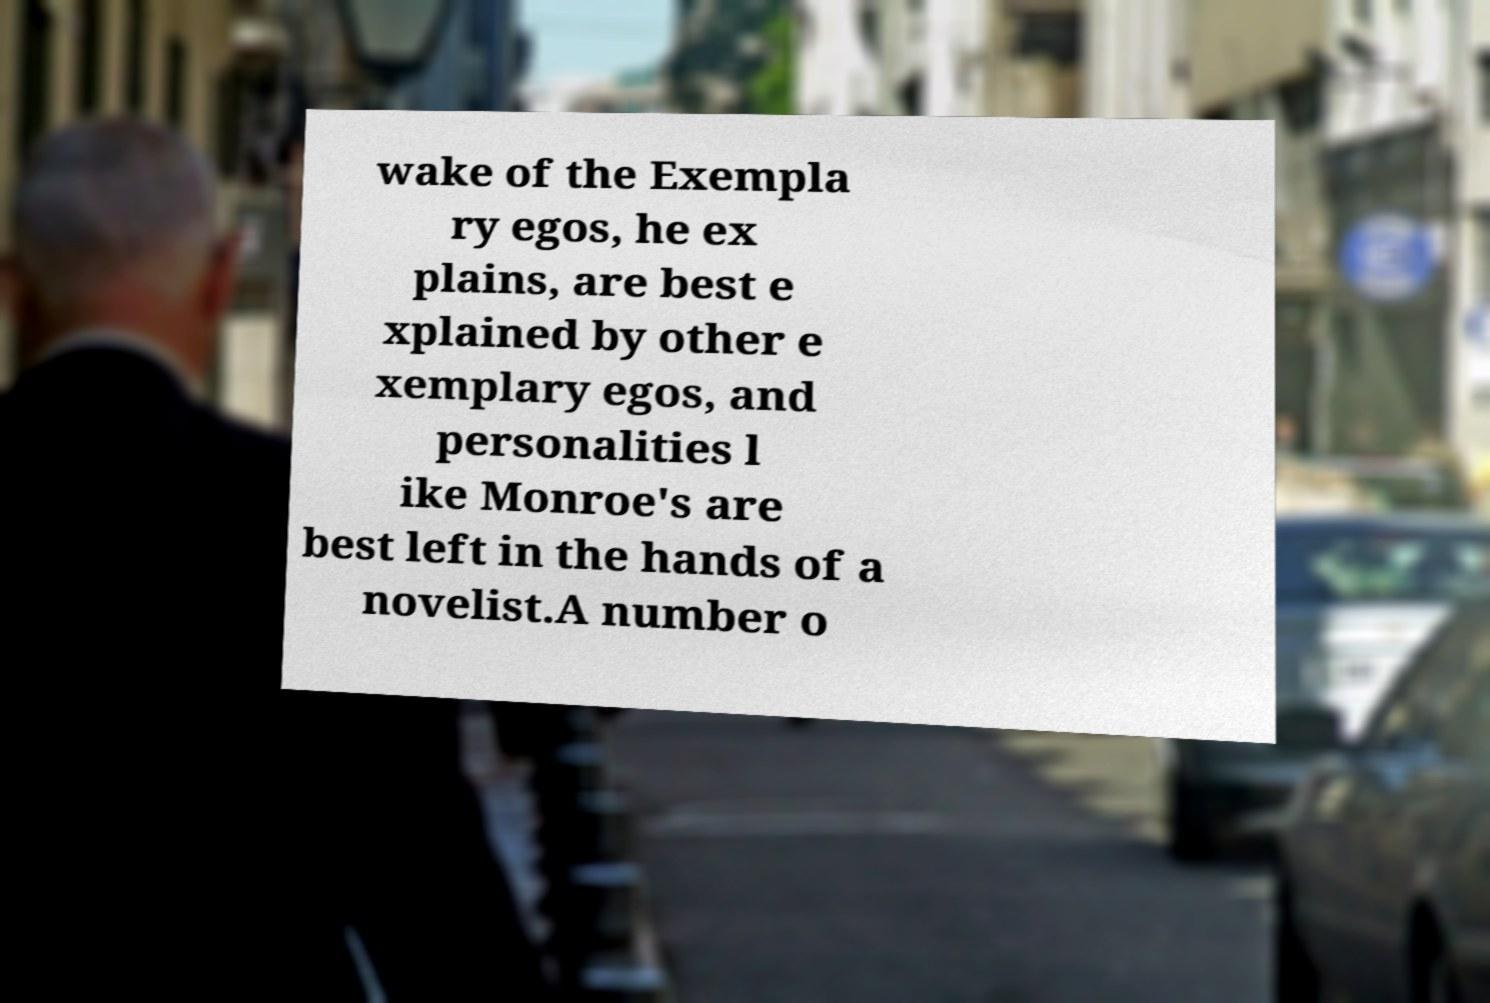What messages or text are displayed in this image? I need them in a readable, typed format. wake of the Exempla ry egos, he ex plains, are best e xplained by other e xemplary egos, and personalities l ike Monroe's are best left in the hands of a novelist.A number o 